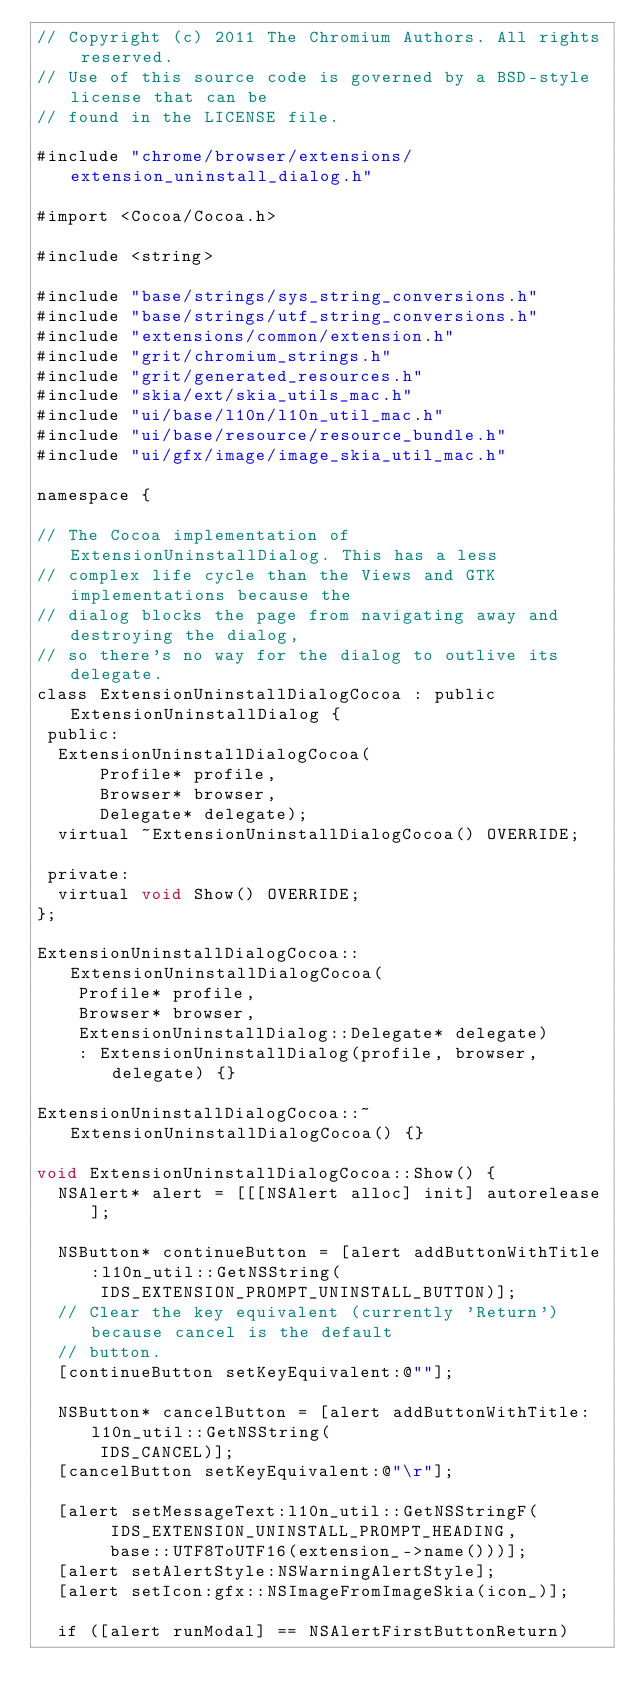<code> <loc_0><loc_0><loc_500><loc_500><_ObjectiveC_>// Copyright (c) 2011 The Chromium Authors. All rights reserved.
// Use of this source code is governed by a BSD-style license that can be
// found in the LICENSE file.

#include "chrome/browser/extensions/extension_uninstall_dialog.h"

#import <Cocoa/Cocoa.h>

#include <string>

#include "base/strings/sys_string_conversions.h"
#include "base/strings/utf_string_conversions.h"
#include "extensions/common/extension.h"
#include "grit/chromium_strings.h"
#include "grit/generated_resources.h"
#include "skia/ext/skia_utils_mac.h"
#include "ui/base/l10n/l10n_util_mac.h"
#include "ui/base/resource/resource_bundle.h"
#include "ui/gfx/image/image_skia_util_mac.h"

namespace {

// The Cocoa implementation of ExtensionUninstallDialog. This has a less
// complex life cycle than the Views and GTK implementations because the
// dialog blocks the page from navigating away and destroying the dialog,
// so there's no way for the dialog to outlive its delegate.
class ExtensionUninstallDialogCocoa : public ExtensionUninstallDialog {
 public:
  ExtensionUninstallDialogCocoa(
      Profile* profile,
      Browser* browser,
      Delegate* delegate);
  virtual ~ExtensionUninstallDialogCocoa() OVERRIDE;

 private:
  virtual void Show() OVERRIDE;
};

ExtensionUninstallDialogCocoa::ExtensionUninstallDialogCocoa(
    Profile* profile,
    Browser* browser,
    ExtensionUninstallDialog::Delegate* delegate)
    : ExtensionUninstallDialog(profile, browser, delegate) {}

ExtensionUninstallDialogCocoa::~ExtensionUninstallDialogCocoa() {}

void ExtensionUninstallDialogCocoa::Show() {
  NSAlert* alert = [[[NSAlert alloc] init] autorelease];

  NSButton* continueButton = [alert addButtonWithTitle:l10n_util::GetNSString(
      IDS_EXTENSION_PROMPT_UNINSTALL_BUTTON)];
  // Clear the key equivalent (currently 'Return') because cancel is the default
  // button.
  [continueButton setKeyEquivalent:@""];

  NSButton* cancelButton = [alert addButtonWithTitle:l10n_util::GetNSString(
      IDS_CANCEL)];
  [cancelButton setKeyEquivalent:@"\r"];

  [alert setMessageText:l10n_util::GetNSStringF(
       IDS_EXTENSION_UNINSTALL_PROMPT_HEADING,
       base::UTF8ToUTF16(extension_->name()))];
  [alert setAlertStyle:NSWarningAlertStyle];
  [alert setIcon:gfx::NSImageFromImageSkia(icon_)];

  if ([alert runModal] == NSAlertFirstButtonReturn)</code> 